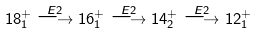<formula> <loc_0><loc_0><loc_500><loc_500>1 8 ^ { + } _ { 1 } \stackrel { E 2 } { \longrightarrow } 1 6 ^ { + } _ { 1 } \stackrel { E 2 } { \longrightarrow } 1 4 ^ { + } _ { 2 } \stackrel { E 2 } { \longrightarrow } 1 2 ^ { + } _ { 1 }</formula> 